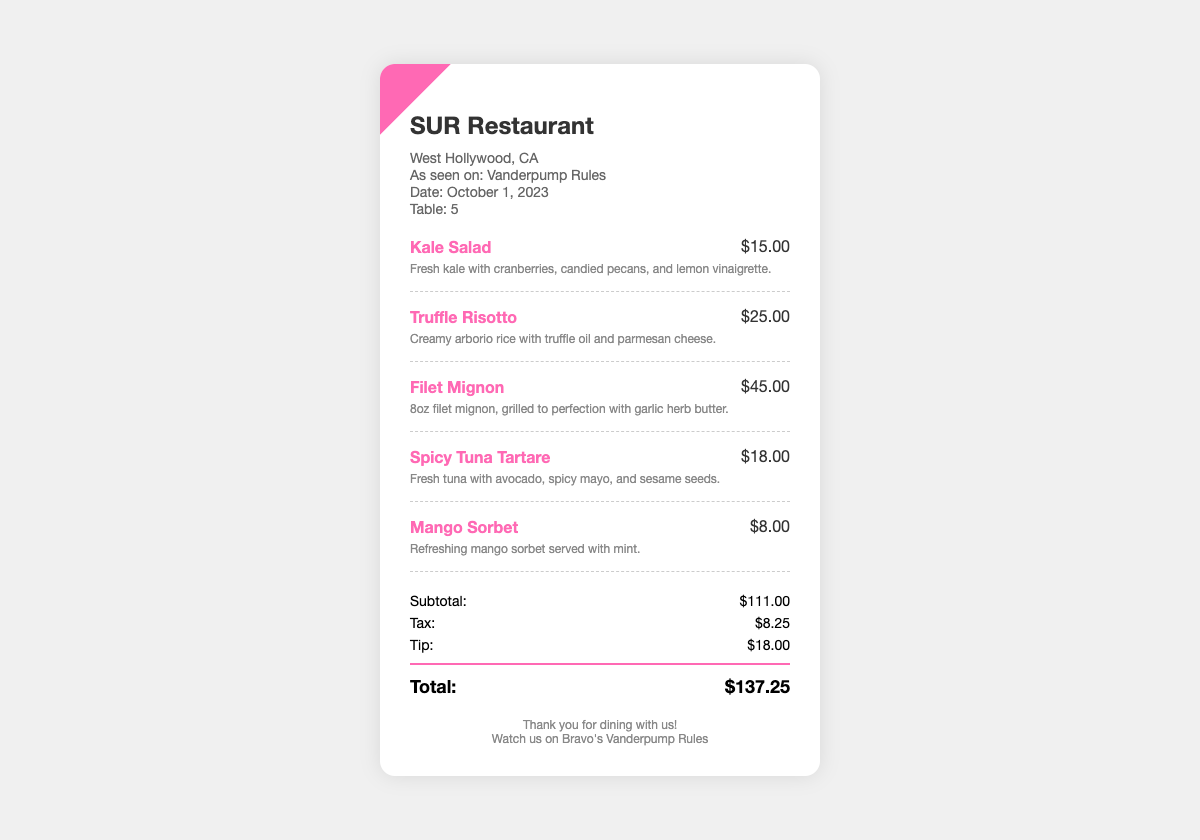What is the date of the bill? The date is specified in the document, indicating when the meal took place.
Answer: October 1, 2023 What is the name of the restaurant? The restaurant name is prominently displayed at the top of the bill.
Answer: SUR Restaurant What is the total cost of the bill? The total cost is highlighted in the grand total section of the bill.
Answer: $137.25 How much was the tip? The tip amount is listed in the totals section of the document.
Answer: $18.00 What was the price of the Filet Mignon? The price for Filet Mignon is shown next to the menu item description.
Answer: $45.00 What item is described as a refreshing dessert? The dessert section of the bill mentions a specific item that fits this description.
Answer: Mango Sorbet How much was the subtotal before tax and tip? The subtotal is clearly listed in the totals area of the document.
Answer: $111.00 How many menu items were ordered? The number of menu items can be counted from the menu items section of the bill.
Answer: 5 What type of cuisine is represented in this bill? The menu items reflect a specific cuisine that can be inferred from their descriptions.
Answer: American What is the location of the restaurant? The location information is provided in the restaurant info section.
Answer: West Hollywood, CA 